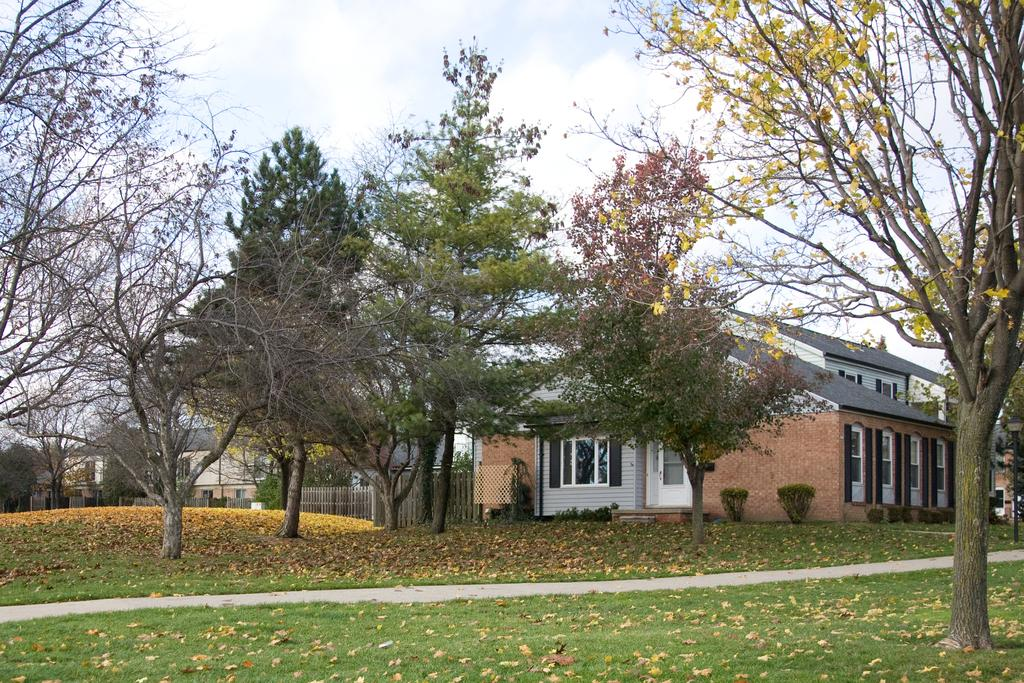What type of vegetation is on the ground in the front of the image? There is grass on the ground in the front of the image. What else can be seen on the ground in the image? There are dry leaves on the ground. What can be seen in the background of the image? There are trees, buildings, and a wooden fence in the background of the image. How would you describe the sky in the image? The sky is cloudy in the image. Can you see a kitty floating in space in the image? There is no kitty or space present in the image; it features a grassy area with trees, buildings, and a wooden fence in the background, and a cloudy sky. What scientific theory is being demonstrated in the image? There is no scientific theory being demonstrated in the image; it is a simple scene of a grassy area with trees, buildings, and a wooden fence in the background, and a cloudy sky. 